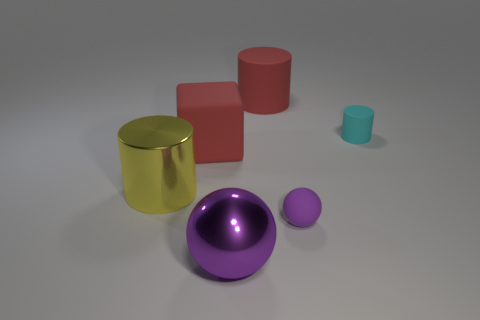Are there any big cyan spheres?
Provide a short and direct response. No. Are there fewer big shiny spheres that are to the right of the small cyan thing than spheres behind the large metal ball?
Your answer should be compact. Yes. The purple thing that is right of the purple shiny sphere has what shape?
Provide a succinct answer. Sphere. Is the large red block made of the same material as the yellow object?
Offer a very short reply. No. Is there anything else that has the same material as the cube?
Offer a terse response. Yes. There is a big yellow object that is the same shape as the cyan object; what material is it?
Make the answer very short. Metal. Is the number of cyan matte objects in front of the cube less than the number of big cyan rubber cylinders?
Give a very brief answer. No. How many large cylinders are behind the small matte cylinder?
Ensure brevity in your answer.  1. Does the tiny matte thing on the left side of the tiny cyan object have the same shape as the big object behind the rubber block?
Give a very brief answer. No. What shape is the matte thing that is to the right of the big metal sphere and in front of the small cyan thing?
Your answer should be very brief. Sphere. 